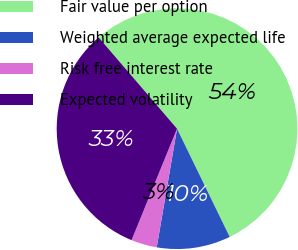Convert chart. <chart><loc_0><loc_0><loc_500><loc_500><pie_chart><fcel>Fair value per option<fcel>Weighted average expected life<fcel>Risk free interest rate<fcel>Expected volatility<nl><fcel>54.09%<fcel>9.91%<fcel>3.47%<fcel>32.54%<nl></chart> 